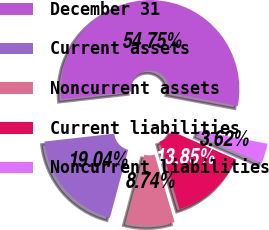Convert chart. <chart><loc_0><loc_0><loc_500><loc_500><pie_chart><fcel>December 31<fcel>Current assets<fcel>Noncurrent assets<fcel>Current liabilities<fcel>Noncurrent liabilities<nl><fcel>54.75%<fcel>19.04%<fcel>8.74%<fcel>13.85%<fcel>3.62%<nl></chart> 